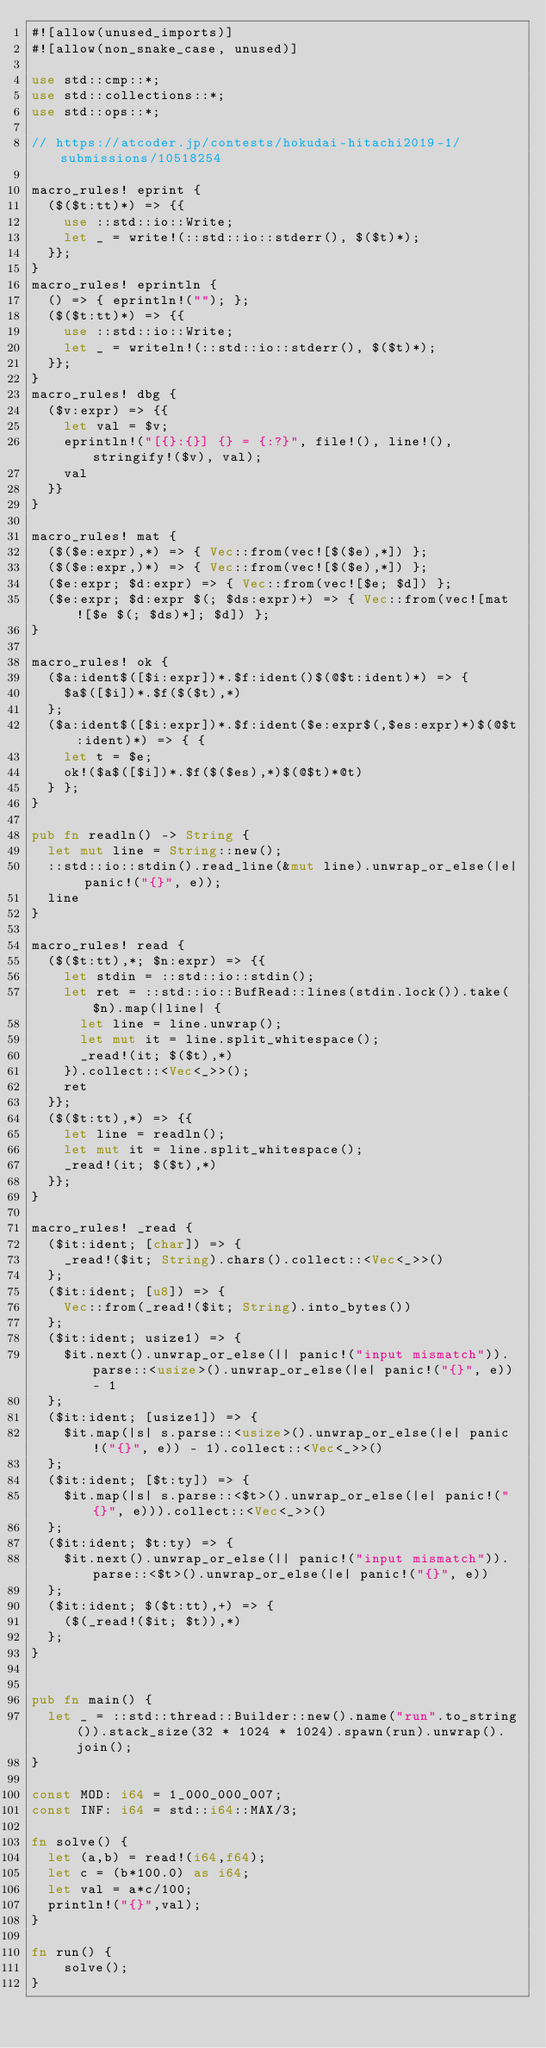Convert code to text. <code><loc_0><loc_0><loc_500><loc_500><_Rust_>#![allow(unused_imports)]
#![allow(non_snake_case, unused)]

use std::cmp::*;
use std::collections::*;
use std::ops::*;

// https://atcoder.jp/contests/hokudai-hitachi2019-1/submissions/10518254

macro_rules! eprint {
	($($t:tt)*) => {{
		use ::std::io::Write;
		let _ = write!(::std::io::stderr(), $($t)*);
	}};
}
macro_rules! eprintln {
	() => { eprintln!(""); };
	($($t:tt)*) => {{
		use ::std::io::Write;
		let _ = writeln!(::std::io::stderr(), $($t)*);
	}};
}
macro_rules! dbg {
	($v:expr) => {{
		let val = $v;
		eprintln!("[{}:{}] {} = {:?}", file!(), line!(), stringify!($v), val);
		val
	}}
}

macro_rules! mat {
	($($e:expr),*) => { Vec::from(vec![$($e),*]) };
	($($e:expr,)*) => { Vec::from(vec![$($e),*]) };
	($e:expr; $d:expr) => { Vec::from(vec![$e; $d]) };
	($e:expr; $d:expr $(; $ds:expr)+) => { Vec::from(vec![mat![$e $(; $ds)*]; $d]) };
}

macro_rules! ok {
	($a:ident$([$i:expr])*.$f:ident()$(@$t:ident)*) => {
		$a$([$i])*.$f($($t),*)
	};
	($a:ident$([$i:expr])*.$f:ident($e:expr$(,$es:expr)*)$(@$t:ident)*) => { {
		let t = $e;
		ok!($a$([$i])*.$f($($es),*)$(@$t)*@t)
	} };
}

pub fn readln() -> String {
	let mut line = String::new();
	::std::io::stdin().read_line(&mut line).unwrap_or_else(|e| panic!("{}", e));
	line
}

macro_rules! read {
	($($t:tt),*; $n:expr) => {{
		let stdin = ::std::io::stdin();
		let ret = ::std::io::BufRead::lines(stdin.lock()).take($n).map(|line| {
			let line = line.unwrap();
			let mut it = line.split_whitespace();
			_read!(it; $($t),*)
		}).collect::<Vec<_>>();
		ret
	}};
	($($t:tt),*) => {{
		let line = readln();
		let mut it = line.split_whitespace();
		_read!(it; $($t),*)
	}};
}

macro_rules! _read {
	($it:ident; [char]) => {
		_read!($it; String).chars().collect::<Vec<_>>()
	};
	($it:ident; [u8]) => {
		Vec::from(_read!($it; String).into_bytes())
	};
	($it:ident; usize1) => {
		$it.next().unwrap_or_else(|| panic!("input mismatch")).parse::<usize>().unwrap_or_else(|e| panic!("{}", e)) - 1
	};
	($it:ident; [usize1]) => {
		$it.map(|s| s.parse::<usize>().unwrap_or_else(|e| panic!("{}", e)) - 1).collect::<Vec<_>>()
	};
	($it:ident; [$t:ty]) => {
		$it.map(|s| s.parse::<$t>().unwrap_or_else(|e| panic!("{}", e))).collect::<Vec<_>>()
	};
	($it:ident; $t:ty) => {
		$it.next().unwrap_or_else(|| panic!("input mismatch")).parse::<$t>().unwrap_or_else(|e| panic!("{}", e))
	};
	($it:ident; $($t:tt),+) => {
		($(_read!($it; $t)),*)
	};
}


pub fn main() {
	let _ = ::std::thread::Builder::new().name("run".to_string()).stack_size(32 * 1024 * 1024).spawn(run).unwrap().join();
}

const MOD: i64 = 1_000_000_007;
const INF: i64 = std::i64::MAX/3;

fn solve() {
	let (a,b) = read!(i64,f64);
	let c = (b*100.0) as i64;
	let val = a*c/100;
	println!("{}",val);
}

fn run() {
    solve();
}
</code> 